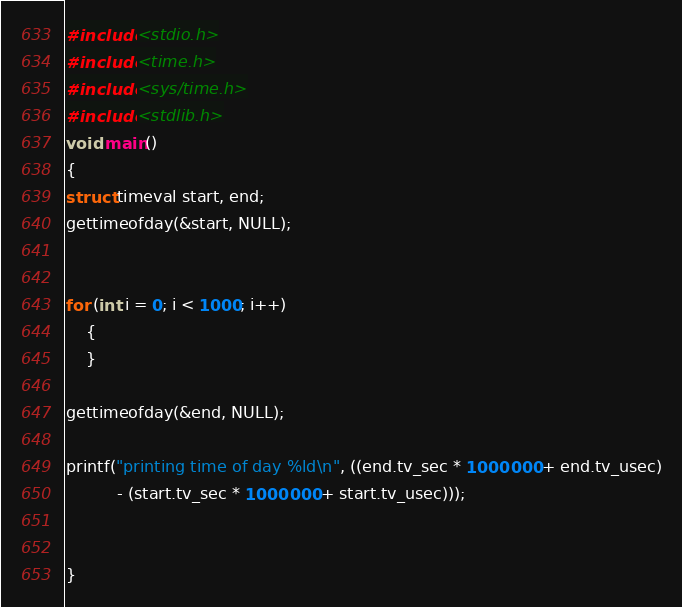<code> <loc_0><loc_0><loc_500><loc_500><_C_>#include<stdio.h>
#include<time.h>
#include<sys/time.h>
#include<stdlib.h>
void main()
{
struct timeval start, end;
gettimeofday(&start, NULL);


for (int i = 0; i < 1000; i++)
    {
    }

gettimeofday(&end, NULL);

printf("printing time of day %ld\n", ((end.tv_sec * 1000000 + end.tv_usec)
		  - (start.tv_sec * 1000000 + start.tv_usec)));


}
</code> 